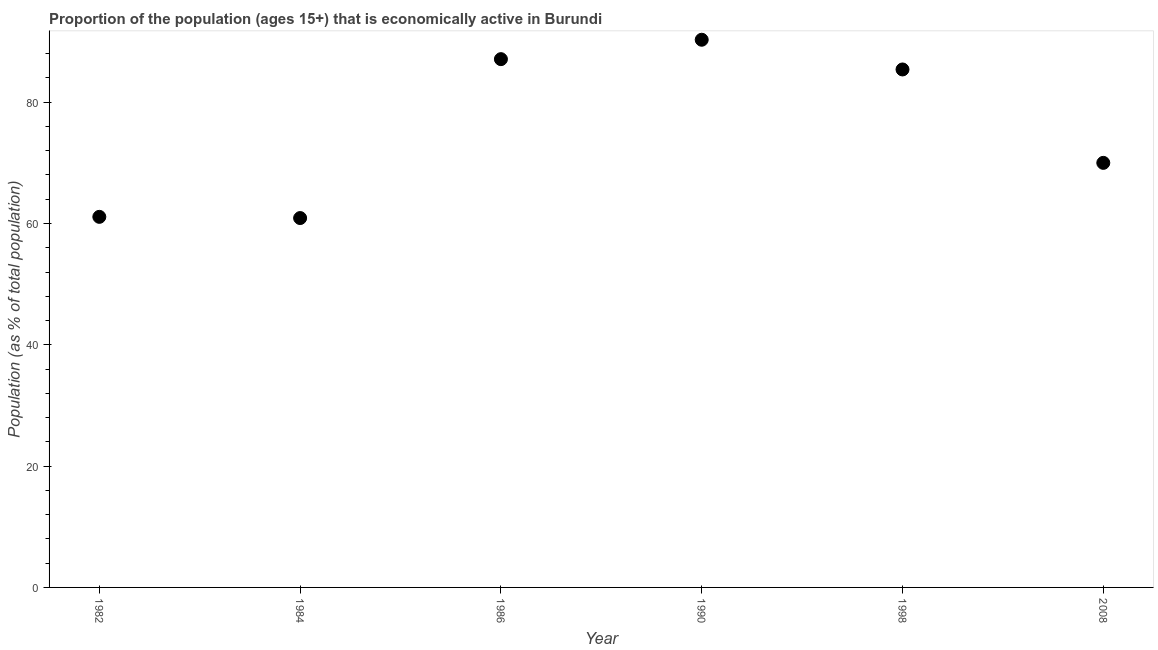What is the percentage of economically active population in 1982?
Give a very brief answer. 61.1. Across all years, what is the maximum percentage of economically active population?
Provide a succinct answer. 90.3. Across all years, what is the minimum percentage of economically active population?
Offer a terse response. 60.9. In which year was the percentage of economically active population maximum?
Offer a very short reply. 1990. What is the sum of the percentage of economically active population?
Your answer should be very brief. 454.8. What is the difference between the percentage of economically active population in 1982 and 1998?
Offer a terse response. -24.3. What is the average percentage of economically active population per year?
Make the answer very short. 75.8. What is the median percentage of economically active population?
Keep it short and to the point. 77.7. In how many years, is the percentage of economically active population greater than 40 %?
Your answer should be very brief. 6. What is the ratio of the percentage of economically active population in 1986 to that in 2008?
Offer a terse response. 1.24. Is the percentage of economically active population in 1982 less than that in 1986?
Keep it short and to the point. Yes. Is the difference between the percentage of economically active population in 1982 and 1990 greater than the difference between any two years?
Provide a short and direct response. No. What is the difference between the highest and the second highest percentage of economically active population?
Offer a very short reply. 3.2. What is the difference between the highest and the lowest percentage of economically active population?
Your answer should be very brief. 29.4. In how many years, is the percentage of economically active population greater than the average percentage of economically active population taken over all years?
Give a very brief answer. 3. How many dotlines are there?
Keep it short and to the point. 1. What is the difference between two consecutive major ticks on the Y-axis?
Provide a succinct answer. 20. What is the title of the graph?
Your answer should be very brief. Proportion of the population (ages 15+) that is economically active in Burundi. What is the label or title of the X-axis?
Make the answer very short. Year. What is the label or title of the Y-axis?
Make the answer very short. Population (as % of total population). What is the Population (as % of total population) in 1982?
Offer a very short reply. 61.1. What is the Population (as % of total population) in 1984?
Give a very brief answer. 60.9. What is the Population (as % of total population) in 1986?
Offer a very short reply. 87.1. What is the Population (as % of total population) in 1990?
Provide a succinct answer. 90.3. What is the Population (as % of total population) in 1998?
Provide a succinct answer. 85.4. What is the difference between the Population (as % of total population) in 1982 and 1984?
Provide a short and direct response. 0.2. What is the difference between the Population (as % of total population) in 1982 and 1990?
Your answer should be very brief. -29.2. What is the difference between the Population (as % of total population) in 1982 and 1998?
Keep it short and to the point. -24.3. What is the difference between the Population (as % of total population) in 1984 and 1986?
Give a very brief answer. -26.2. What is the difference between the Population (as % of total population) in 1984 and 1990?
Make the answer very short. -29.4. What is the difference between the Population (as % of total population) in 1984 and 1998?
Make the answer very short. -24.5. What is the difference between the Population (as % of total population) in 1984 and 2008?
Offer a terse response. -9.1. What is the difference between the Population (as % of total population) in 1986 and 1990?
Your answer should be compact. -3.2. What is the difference between the Population (as % of total population) in 1986 and 2008?
Provide a succinct answer. 17.1. What is the difference between the Population (as % of total population) in 1990 and 2008?
Your answer should be very brief. 20.3. What is the ratio of the Population (as % of total population) in 1982 to that in 1986?
Make the answer very short. 0.7. What is the ratio of the Population (as % of total population) in 1982 to that in 1990?
Your response must be concise. 0.68. What is the ratio of the Population (as % of total population) in 1982 to that in 1998?
Ensure brevity in your answer.  0.71. What is the ratio of the Population (as % of total population) in 1982 to that in 2008?
Make the answer very short. 0.87. What is the ratio of the Population (as % of total population) in 1984 to that in 1986?
Ensure brevity in your answer.  0.7. What is the ratio of the Population (as % of total population) in 1984 to that in 1990?
Keep it short and to the point. 0.67. What is the ratio of the Population (as % of total population) in 1984 to that in 1998?
Your response must be concise. 0.71. What is the ratio of the Population (as % of total population) in 1984 to that in 2008?
Provide a succinct answer. 0.87. What is the ratio of the Population (as % of total population) in 1986 to that in 1998?
Your response must be concise. 1.02. What is the ratio of the Population (as % of total population) in 1986 to that in 2008?
Offer a very short reply. 1.24. What is the ratio of the Population (as % of total population) in 1990 to that in 1998?
Give a very brief answer. 1.06. What is the ratio of the Population (as % of total population) in 1990 to that in 2008?
Your answer should be compact. 1.29. What is the ratio of the Population (as % of total population) in 1998 to that in 2008?
Your answer should be very brief. 1.22. 